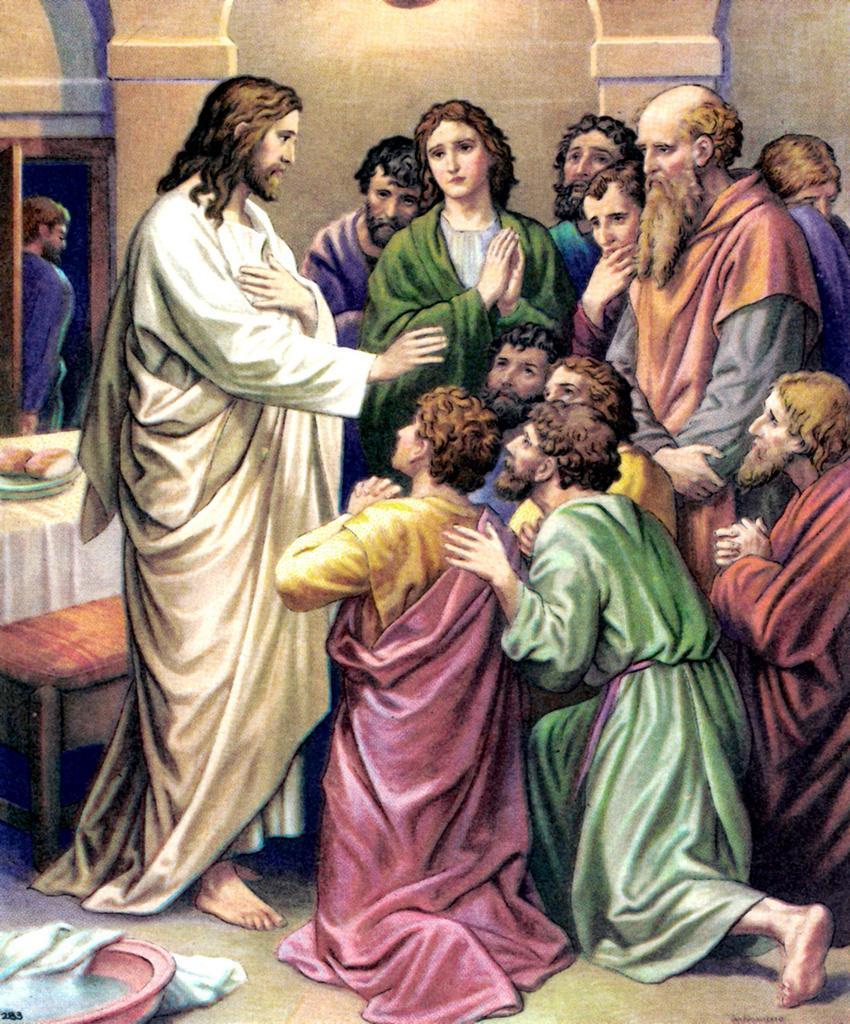Could you give a brief overview of what you see in this image? This image is an animated image. At the bottom of the image there is a floor. There is a cloth on the floor. In the background there is a wall with a door and a man is standing. There is a table with a tablecloth and a plate with buns on it and there is a bench. In the middle of the image a few are standing and a few are sitting. 